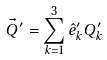<formula> <loc_0><loc_0><loc_500><loc_500>\vec { Q } ^ { \prime } = \sum _ { k = 1 } ^ { 3 } \hat { e } ^ { \prime } _ { k } Q ^ { \prime } _ { k }</formula> 